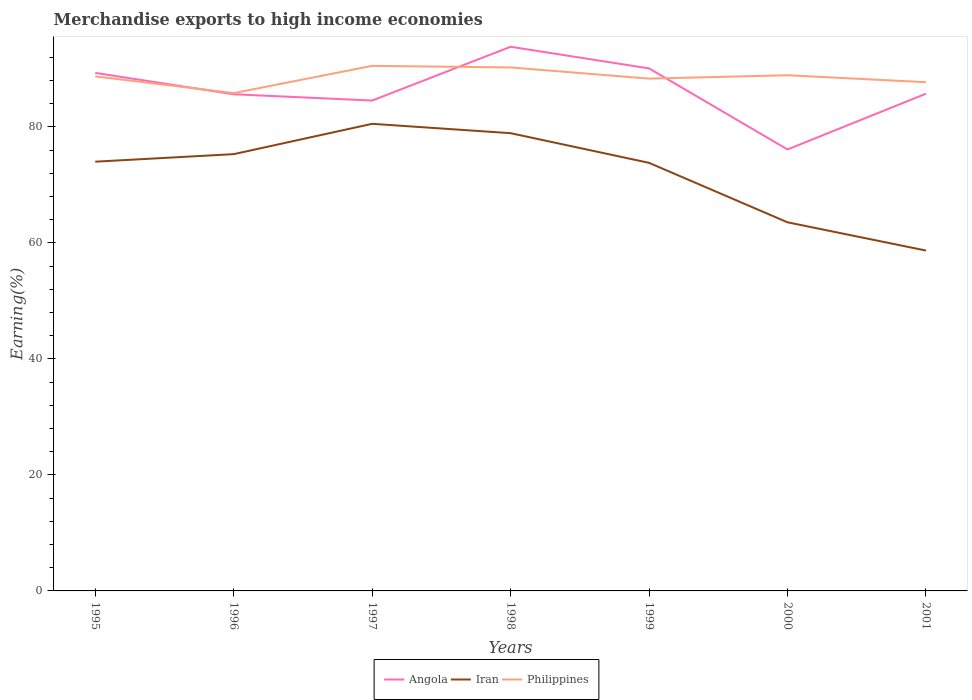How many different coloured lines are there?
Ensure brevity in your answer.  3. Is the number of lines equal to the number of legend labels?
Your answer should be very brief. Yes. Across all years, what is the maximum percentage of amount earned from merchandise exports in Iran?
Your response must be concise. 58.69. What is the total percentage of amount earned from merchandise exports in Angola in the graph?
Your response must be concise. -8.19. What is the difference between the highest and the second highest percentage of amount earned from merchandise exports in Iran?
Your response must be concise. 21.85. Is the percentage of amount earned from merchandise exports in Iran strictly greater than the percentage of amount earned from merchandise exports in Philippines over the years?
Give a very brief answer. Yes. How many lines are there?
Offer a terse response. 3. Are the values on the major ticks of Y-axis written in scientific E-notation?
Make the answer very short. No. Does the graph contain any zero values?
Provide a short and direct response. No. Does the graph contain grids?
Provide a short and direct response. No. Where does the legend appear in the graph?
Ensure brevity in your answer.  Bottom center. How many legend labels are there?
Ensure brevity in your answer.  3. What is the title of the graph?
Your answer should be compact. Merchandise exports to high income economies. What is the label or title of the Y-axis?
Provide a succinct answer. Earning(%). What is the Earning(%) of Angola in 1995?
Your answer should be very brief. 89.32. What is the Earning(%) in Iran in 1995?
Keep it short and to the point. 74.01. What is the Earning(%) in Philippines in 1995?
Give a very brief answer. 88.72. What is the Earning(%) in Angola in 1996?
Ensure brevity in your answer.  85.63. What is the Earning(%) of Iran in 1996?
Offer a very short reply. 75.31. What is the Earning(%) of Philippines in 1996?
Provide a succinct answer. 85.83. What is the Earning(%) in Angola in 1997?
Your answer should be compact. 84.55. What is the Earning(%) in Iran in 1997?
Provide a short and direct response. 80.54. What is the Earning(%) of Philippines in 1997?
Provide a succinct answer. 90.53. What is the Earning(%) in Angola in 1998?
Offer a very short reply. 93.83. What is the Earning(%) in Iran in 1998?
Your response must be concise. 78.93. What is the Earning(%) in Philippines in 1998?
Provide a succinct answer. 90.26. What is the Earning(%) of Angola in 1999?
Give a very brief answer. 90.09. What is the Earning(%) of Iran in 1999?
Give a very brief answer. 73.81. What is the Earning(%) in Philippines in 1999?
Keep it short and to the point. 88.33. What is the Earning(%) in Angola in 2000?
Give a very brief answer. 76.12. What is the Earning(%) in Iran in 2000?
Offer a terse response. 63.56. What is the Earning(%) of Philippines in 2000?
Offer a very short reply. 88.91. What is the Earning(%) in Angola in 2001?
Keep it short and to the point. 85.73. What is the Earning(%) of Iran in 2001?
Your response must be concise. 58.69. What is the Earning(%) of Philippines in 2001?
Keep it short and to the point. 87.72. Across all years, what is the maximum Earning(%) of Angola?
Ensure brevity in your answer.  93.83. Across all years, what is the maximum Earning(%) of Iran?
Provide a short and direct response. 80.54. Across all years, what is the maximum Earning(%) in Philippines?
Provide a short and direct response. 90.53. Across all years, what is the minimum Earning(%) in Angola?
Offer a terse response. 76.12. Across all years, what is the minimum Earning(%) in Iran?
Your answer should be compact. 58.69. Across all years, what is the minimum Earning(%) in Philippines?
Your answer should be compact. 85.83. What is the total Earning(%) of Angola in the graph?
Offer a very short reply. 605.28. What is the total Earning(%) in Iran in the graph?
Your response must be concise. 504.84. What is the total Earning(%) in Philippines in the graph?
Your answer should be compact. 620.31. What is the difference between the Earning(%) in Angola in 1995 and that in 1996?
Your answer should be very brief. 3.69. What is the difference between the Earning(%) of Iran in 1995 and that in 1996?
Give a very brief answer. -1.3. What is the difference between the Earning(%) in Philippines in 1995 and that in 1996?
Provide a succinct answer. 2.89. What is the difference between the Earning(%) in Angola in 1995 and that in 1997?
Provide a succinct answer. 4.77. What is the difference between the Earning(%) of Iran in 1995 and that in 1997?
Provide a succinct answer. -6.53. What is the difference between the Earning(%) in Philippines in 1995 and that in 1997?
Keep it short and to the point. -1.81. What is the difference between the Earning(%) in Angola in 1995 and that in 1998?
Offer a very short reply. -4.51. What is the difference between the Earning(%) in Iran in 1995 and that in 1998?
Offer a very short reply. -4.92. What is the difference between the Earning(%) in Philippines in 1995 and that in 1998?
Offer a terse response. -1.54. What is the difference between the Earning(%) in Angola in 1995 and that in 1999?
Keep it short and to the point. -0.78. What is the difference between the Earning(%) of Iran in 1995 and that in 1999?
Your answer should be compact. 0.2. What is the difference between the Earning(%) in Philippines in 1995 and that in 1999?
Provide a succinct answer. 0.39. What is the difference between the Earning(%) in Angola in 1995 and that in 2000?
Provide a succinct answer. 13.2. What is the difference between the Earning(%) in Iran in 1995 and that in 2000?
Offer a terse response. 10.45. What is the difference between the Earning(%) of Philippines in 1995 and that in 2000?
Give a very brief answer. -0.19. What is the difference between the Earning(%) of Angola in 1995 and that in 2001?
Your response must be concise. 3.59. What is the difference between the Earning(%) of Iran in 1995 and that in 2001?
Your answer should be very brief. 15.32. What is the difference between the Earning(%) of Angola in 1996 and that in 1997?
Offer a very short reply. 1.08. What is the difference between the Earning(%) in Iran in 1996 and that in 1997?
Offer a very short reply. -5.23. What is the difference between the Earning(%) of Philippines in 1996 and that in 1997?
Your answer should be compact. -4.7. What is the difference between the Earning(%) in Angola in 1996 and that in 1998?
Provide a succinct answer. -8.19. What is the difference between the Earning(%) of Iran in 1996 and that in 1998?
Your response must be concise. -3.62. What is the difference between the Earning(%) in Philippines in 1996 and that in 1998?
Offer a very short reply. -4.43. What is the difference between the Earning(%) of Angola in 1996 and that in 1999?
Ensure brevity in your answer.  -4.46. What is the difference between the Earning(%) of Iran in 1996 and that in 1999?
Keep it short and to the point. 1.5. What is the difference between the Earning(%) of Philippines in 1996 and that in 1999?
Your answer should be compact. -2.5. What is the difference between the Earning(%) in Angola in 1996 and that in 2000?
Provide a succinct answer. 9.52. What is the difference between the Earning(%) in Iran in 1996 and that in 2000?
Give a very brief answer. 11.75. What is the difference between the Earning(%) of Philippines in 1996 and that in 2000?
Your answer should be very brief. -3.08. What is the difference between the Earning(%) of Angola in 1996 and that in 2001?
Your answer should be compact. -0.1. What is the difference between the Earning(%) of Iran in 1996 and that in 2001?
Your response must be concise. 16.62. What is the difference between the Earning(%) of Philippines in 1996 and that in 2001?
Offer a terse response. -1.88. What is the difference between the Earning(%) in Angola in 1997 and that in 1998?
Offer a terse response. -9.27. What is the difference between the Earning(%) in Iran in 1997 and that in 1998?
Your answer should be compact. 1.61. What is the difference between the Earning(%) in Philippines in 1997 and that in 1998?
Your answer should be compact. 0.27. What is the difference between the Earning(%) in Angola in 1997 and that in 1999?
Keep it short and to the point. -5.54. What is the difference between the Earning(%) in Iran in 1997 and that in 1999?
Your answer should be very brief. 6.73. What is the difference between the Earning(%) in Philippines in 1997 and that in 1999?
Offer a very short reply. 2.2. What is the difference between the Earning(%) of Angola in 1997 and that in 2000?
Your response must be concise. 8.43. What is the difference between the Earning(%) in Iran in 1997 and that in 2000?
Your answer should be very brief. 16.98. What is the difference between the Earning(%) of Philippines in 1997 and that in 2000?
Your response must be concise. 1.62. What is the difference between the Earning(%) in Angola in 1997 and that in 2001?
Your response must be concise. -1.18. What is the difference between the Earning(%) of Iran in 1997 and that in 2001?
Give a very brief answer. 21.85. What is the difference between the Earning(%) of Philippines in 1997 and that in 2001?
Offer a very short reply. 2.82. What is the difference between the Earning(%) of Angola in 1998 and that in 1999?
Offer a terse response. 3.73. What is the difference between the Earning(%) of Iran in 1998 and that in 1999?
Keep it short and to the point. 5.12. What is the difference between the Earning(%) in Philippines in 1998 and that in 1999?
Ensure brevity in your answer.  1.93. What is the difference between the Earning(%) in Angola in 1998 and that in 2000?
Ensure brevity in your answer.  17.71. What is the difference between the Earning(%) of Iran in 1998 and that in 2000?
Provide a short and direct response. 15.37. What is the difference between the Earning(%) of Philippines in 1998 and that in 2000?
Keep it short and to the point. 1.35. What is the difference between the Earning(%) in Angola in 1998 and that in 2001?
Make the answer very short. 8.09. What is the difference between the Earning(%) in Iran in 1998 and that in 2001?
Your answer should be compact. 20.24. What is the difference between the Earning(%) in Philippines in 1998 and that in 2001?
Ensure brevity in your answer.  2.54. What is the difference between the Earning(%) of Angola in 1999 and that in 2000?
Give a very brief answer. 13.98. What is the difference between the Earning(%) in Iran in 1999 and that in 2000?
Provide a short and direct response. 10.25. What is the difference between the Earning(%) in Philippines in 1999 and that in 2000?
Your answer should be very brief. -0.58. What is the difference between the Earning(%) of Angola in 1999 and that in 2001?
Offer a very short reply. 4.36. What is the difference between the Earning(%) in Iran in 1999 and that in 2001?
Offer a terse response. 15.12. What is the difference between the Earning(%) in Philippines in 1999 and that in 2001?
Your answer should be very brief. 0.62. What is the difference between the Earning(%) of Angola in 2000 and that in 2001?
Offer a very short reply. -9.61. What is the difference between the Earning(%) in Iran in 2000 and that in 2001?
Give a very brief answer. 4.87. What is the difference between the Earning(%) of Philippines in 2000 and that in 2001?
Your response must be concise. 1.2. What is the difference between the Earning(%) in Angola in 1995 and the Earning(%) in Iran in 1996?
Your answer should be compact. 14.01. What is the difference between the Earning(%) in Angola in 1995 and the Earning(%) in Philippines in 1996?
Offer a very short reply. 3.49. What is the difference between the Earning(%) of Iran in 1995 and the Earning(%) of Philippines in 1996?
Give a very brief answer. -11.82. What is the difference between the Earning(%) of Angola in 1995 and the Earning(%) of Iran in 1997?
Provide a short and direct response. 8.78. What is the difference between the Earning(%) in Angola in 1995 and the Earning(%) in Philippines in 1997?
Make the answer very short. -1.21. What is the difference between the Earning(%) of Iran in 1995 and the Earning(%) of Philippines in 1997?
Offer a terse response. -16.52. What is the difference between the Earning(%) of Angola in 1995 and the Earning(%) of Iran in 1998?
Provide a short and direct response. 10.39. What is the difference between the Earning(%) of Angola in 1995 and the Earning(%) of Philippines in 1998?
Keep it short and to the point. -0.94. What is the difference between the Earning(%) of Iran in 1995 and the Earning(%) of Philippines in 1998?
Your answer should be very brief. -16.25. What is the difference between the Earning(%) of Angola in 1995 and the Earning(%) of Iran in 1999?
Provide a short and direct response. 15.51. What is the difference between the Earning(%) of Angola in 1995 and the Earning(%) of Philippines in 1999?
Keep it short and to the point. 0.99. What is the difference between the Earning(%) in Iran in 1995 and the Earning(%) in Philippines in 1999?
Give a very brief answer. -14.32. What is the difference between the Earning(%) of Angola in 1995 and the Earning(%) of Iran in 2000?
Make the answer very short. 25.76. What is the difference between the Earning(%) of Angola in 1995 and the Earning(%) of Philippines in 2000?
Offer a very short reply. 0.41. What is the difference between the Earning(%) of Iran in 1995 and the Earning(%) of Philippines in 2000?
Offer a very short reply. -14.9. What is the difference between the Earning(%) in Angola in 1995 and the Earning(%) in Iran in 2001?
Your answer should be compact. 30.63. What is the difference between the Earning(%) of Angola in 1995 and the Earning(%) of Philippines in 2001?
Give a very brief answer. 1.6. What is the difference between the Earning(%) in Iran in 1995 and the Earning(%) in Philippines in 2001?
Offer a terse response. -13.7. What is the difference between the Earning(%) in Angola in 1996 and the Earning(%) in Iran in 1997?
Offer a very short reply. 5.09. What is the difference between the Earning(%) in Angola in 1996 and the Earning(%) in Philippines in 1997?
Provide a succinct answer. -4.9. What is the difference between the Earning(%) of Iran in 1996 and the Earning(%) of Philippines in 1997?
Your answer should be very brief. -15.22. What is the difference between the Earning(%) of Angola in 1996 and the Earning(%) of Iran in 1998?
Provide a short and direct response. 6.71. What is the difference between the Earning(%) of Angola in 1996 and the Earning(%) of Philippines in 1998?
Provide a succinct answer. -4.63. What is the difference between the Earning(%) of Iran in 1996 and the Earning(%) of Philippines in 1998?
Give a very brief answer. -14.95. What is the difference between the Earning(%) of Angola in 1996 and the Earning(%) of Iran in 1999?
Make the answer very short. 11.83. What is the difference between the Earning(%) in Angola in 1996 and the Earning(%) in Philippines in 1999?
Keep it short and to the point. -2.7. What is the difference between the Earning(%) in Iran in 1996 and the Earning(%) in Philippines in 1999?
Your answer should be compact. -13.02. What is the difference between the Earning(%) in Angola in 1996 and the Earning(%) in Iran in 2000?
Offer a very short reply. 22.08. What is the difference between the Earning(%) of Angola in 1996 and the Earning(%) of Philippines in 2000?
Offer a very short reply. -3.28. What is the difference between the Earning(%) in Iran in 1996 and the Earning(%) in Philippines in 2000?
Make the answer very short. -13.6. What is the difference between the Earning(%) of Angola in 1996 and the Earning(%) of Iran in 2001?
Your answer should be very brief. 26.95. What is the difference between the Earning(%) in Angola in 1996 and the Earning(%) in Philippines in 2001?
Your answer should be compact. -2.08. What is the difference between the Earning(%) of Iran in 1996 and the Earning(%) of Philippines in 2001?
Give a very brief answer. -12.41. What is the difference between the Earning(%) of Angola in 1997 and the Earning(%) of Iran in 1998?
Your answer should be compact. 5.63. What is the difference between the Earning(%) in Angola in 1997 and the Earning(%) in Philippines in 1998?
Make the answer very short. -5.71. What is the difference between the Earning(%) of Iran in 1997 and the Earning(%) of Philippines in 1998?
Offer a terse response. -9.72. What is the difference between the Earning(%) of Angola in 1997 and the Earning(%) of Iran in 1999?
Provide a short and direct response. 10.74. What is the difference between the Earning(%) in Angola in 1997 and the Earning(%) in Philippines in 1999?
Ensure brevity in your answer.  -3.78. What is the difference between the Earning(%) of Iran in 1997 and the Earning(%) of Philippines in 1999?
Provide a short and direct response. -7.79. What is the difference between the Earning(%) in Angola in 1997 and the Earning(%) in Iran in 2000?
Your answer should be very brief. 20.99. What is the difference between the Earning(%) of Angola in 1997 and the Earning(%) of Philippines in 2000?
Your answer should be very brief. -4.36. What is the difference between the Earning(%) of Iran in 1997 and the Earning(%) of Philippines in 2000?
Your response must be concise. -8.37. What is the difference between the Earning(%) in Angola in 1997 and the Earning(%) in Iran in 2001?
Keep it short and to the point. 25.86. What is the difference between the Earning(%) in Angola in 1997 and the Earning(%) in Philippines in 2001?
Provide a short and direct response. -3.16. What is the difference between the Earning(%) in Iran in 1997 and the Earning(%) in Philippines in 2001?
Give a very brief answer. -7.18. What is the difference between the Earning(%) in Angola in 1998 and the Earning(%) in Iran in 1999?
Your answer should be compact. 20.02. What is the difference between the Earning(%) of Angola in 1998 and the Earning(%) of Philippines in 1999?
Make the answer very short. 5.49. What is the difference between the Earning(%) in Iran in 1998 and the Earning(%) in Philippines in 1999?
Your response must be concise. -9.41. What is the difference between the Earning(%) of Angola in 1998 and the Earning(%) of Iran in 2000?
Make the answer very short. 30.27. What is the difference between the Earning(%) of Angola in 1998 and the Earning(%) of Philippines in 2000?
Ensure brevity in your answer.  4.91. What is the difference between the Earning(%) of Iran in 1998 and the Earning(%) of Philippines in 2000?
Offer a very short reply. -9.99. What is the difference between the Earning(%) of Angola in 1998 and the Earning(%) of Iran in 2001?
Ensure brevity in your answer.  35.14. What is the difference between the Earning(%) of Angola in 1998 and the Earning(%) of Philippines in 2001?
Make the answer very short. 6.11. What is the difference between the Earning(%) in Iran in 1998 and the Earning(%) in Philippines in 2001?
Your answer should be very brief. -8.79. What is the difference between the Earning(%) of Angola in 1999 and the Earning(%) of Iran in 2000?
Offer a terse response. 26.54. What is the difference between the Earning(%) of Angola in 1999 and the Earning(%) of Philippines in 2000?
Offer a very short reply. 1.18. What is the difference between the Earning(%) of Iran in 1999 and the Earning(%) of Philippines in 2000?
Keep it short and to the point. -15.11. What is the difference between the Earning(%) in Angola in 1999 and the Earning(%) in Iran in 2001?
Provide a short and direct response. 31.41. What is the difference between the Earning(%) in Angola in 1999 and the Earning(%) in Philippines in 2001?
Make the answer very short. 2.38. What is the difference between the Earning(%) in Iran in 1999 and the Earning(%) in Philippines in 2001?
Keep it short and to the point. -13.91. What is the difference between the Earning(%) of Angola in 2000 and the Earning(%) of Iran in 2001?
Your response must be concise. 17.43. What is the difference between the Earning(%) in Angola in 2000 and the Earning(%) in Philippines in 2001?
Provide a succinct answer. -11.6. What is the difference between the Earning(%) in Iran in 2000 and the Earning(%) in Philippines in 2001?
Your answer should be very brief. -24.16. What is the average Earning(%) in Angola per year?
Ensure brevity in your answer.  86.47. What is the average Earning(%) of Iran per year?
Keep it short and to the point. 72.12. What is the average Earning(%) of Philippines per year?
Offer a very short reply. 88.62. In the year 1995, what is the difference between the Earning(%) of Angola and Earning(%) of Iran?
Give a very brief answer. 15.31. In the year 1995, what is the difference between the Earning(%) of Angola and Earning(%) of Philippines?
Make the answer very short. 0.6. In the year 1995, what is the difference between the Earning(%) in Iran and Earning(%) in Philippines?
Your answer should be very brief. -14.71. In the year 1996, what is the difference between the Earning(%) in Angola and Earning(%) in Iran?
Ensure brevity in your answer.  10.32. In the year 1996, what is the difference between the Earning(%) in Angola and Earning(%) in Philippines?
Keep it short and to the point. -0.2. In the year 1996, what is the difference between the Earning(%) in Iran and Earning(%) in Philippines?
Your answer should be compact. -10.52. In the year 1997, what is the difference between the Earning(%) of Angola and Earning(%) of Iran?
Your answer should be very brief. 4.01. In the year 1997, what is the difference between the Earning(%) in Angola and Earning(%) in Philippines?
Give a very brief answer. -5.98. In the year 1997, what is the difference between the Earning(%) of Iran and Earning(%) of Philippines?
Provide a succinct answer. -9.99. In the year 1998, what is the difference between the Earning(%) in Angola and Earning(%) in Iran?
Give a very brief answer. 14.9. In the year 1998, what is the difference between the Earning(%) in Angola and Earning(%) in Philippines?
Make the answer very short. 3.57. In the year 1998, what is the difference between the Earning(%) in Iran and Earning(%) in Philippines?
Your response must be concise. -11.33. In the year 1999, what is the difference between the Earning(%) of Angola and Earning(%) of Iran?
Make the answer very short. 16.29. In the year 1999, what is the difference between the Earning(%) in Angola and Earning(%) in Philippines?
Offer a terse response. 1.76. In the year 1999, what is the difference between the Earning(%) in Iran and Earning(%) in Philippines?
Ensure brevity in your answer.  -14.52. In the year 2000, what is the difference between the Earning(%) of Angola and Earning(%) of Iran?
Give a very brief answer. 12.56. In the year 2000, what is the difference between the Earning(%) in Angola and Earning(%) in Philippines?
Make the answer very short. -12.79. In the year 2000, what is the difference between the Earning(%) in Iran and Earning(%) in Philippines?
Your answer should be compact. -25.36. In the year 2001, what is the difference between the Earning(%) in Angola and Earning(%) in Iran?
Provide a short and direct response. 27.04. In the year 2001, what is the difference between the Earning(%) of Angola and Earning(%) of Philippines?
Make the answer very short. -1.98. In the year 2001, what is the difference between the Earning(%) in Iran and Earning(%) in Philippines?
Your response must be concise. -29.03. What is the ratio of the Earning(%) of Angola in 1995 to that in 1996?
Keep it short and to the point. 1.04. What is the ratio of the Earning(%) in Iran in 1995 to that in 1996?
Ensure brevity in your answer.  0.98. What is the ratio of the Earning(%) in Philippines in 1995 to that in 1996?
Ensure brevity in your answer.  1.03. What is the ratio of the Earning(%) of Angola in 1995 to that in 1997?
Give a very brief answer. 1.06. What is the ratio of the Earning(%) in Iran in 1995 to that in 1997?
Give a very brief answer. 0.92. What is the ratio of the Earning(%) in Iran in 1995 to that in 1998?
Provide a succinct answer. 0.94. What is the ratio of the Earning(%) of Philippines in 1995 to that in 1998?
Offer a very short reply. 0.98. What is the ratio of the Earning(%) in Philippines in 1995 to that in 1999?
Provide a succinct answer. 1. What is the ratio of the Earning(%) in Angola in 1995 to that in 2000?
Offer a very short reply. 1.17. What is the ratio of the Earning(%) in Iran in 1995 to that in 2000?
Your answer should be very brief. 1.16. What is the ratio of the Earning(%) of Philippines in 1995 to that in 2000?
Provide a succinct answer. 1. What is the ratio of the Earning(%) in Angola in 1995 to that in 2001?
Give a very brief answer. 1.04. What is the ratio of the Earning(%) of Iran in 1995 to that in 2001?
Give a very brief answer. 1.26. What is the ratio of the Earning(%) in Philippines in 1995 to that in 2001?
Your response must be concise. 1.01. What is the ratio of the Earning(%) in Angola in 1996 to that in 1997?
Provide a short and direct response. 1.01. What is the ratio of the Earning(%) of Iran in 1996 to that in 1997?
Make the answer very short. 0.94. What is the ratio of the Earning(%) in Philippines in 1996 to that in 1997?
Make the answer very short. 0.95. What is the ratio of the Earning(%) of Angola in 1996 to that in 1998?
Ensure brevity in your answer.  0.91. What is the ratio of the Earning(%) in Iran in 1996 to that in 1998?
Make the answer very short. 0.95. What is the ratio of the Earning(%) of Philippines in 1996 to that in 1998?
Keep it short and to the point. 0.95. What is the ratio of the Earning(%) in Angola in 1996 to that in 1999?
Provide a succinct answer. 0.95. What is the ratio of the Earning(%) in Iran in 1996 to that in 1999?
Your response must be concise. 1.02. What is the ratio of the Earning(%) of Philippines in 1996 to that in 1999?
Ensure brevity in your answer.  0.97. What is the ratio of the Earning(%) of Iran in 1996 to that in 2000?
Your answer should be very brief. 1.18. What is the ratio of the Earning(%) of Philippines in 1996 to that in 2000?
Your response must be concise. 0.97. What is the ratio of the Earning(%) of Angola in 1996 to that in 2001?
Your response must be concise. 1. What is the ratio of the Earning(%) of Iran in 1996 to that in 2001?
Your response must be concise. 1.28. What is the ratio of the Earning(%) of Philippines in 1996 to that in 2001?
Provide a succinct answer. 0.98. What is the ratio of the Earning(%) in Angola in 1997 to that in 1998?
Make the answer very short. 0.9. What is the ratio of the Earning(%) of Iran in 1997 to that in 1998?
Offer a terse response. 1.02. What is the ratio of the Earning(%) in Angola in 1997 to that in 1999?
Give a very brief answer. 0.94. What is the ratio of the Earning(%) of Iran in 1997 to that in 1999?
Give a very brief answer. 1.09. What is the ratio of the Earning(%) in Philippines in 1997 to that in 1999?
Provide a short and direct response. 1.02. What is the ratio of the Earning(%) in Angola in 1997 to that in 2000?
Your response must be concise. 1.11. What is the ratio of the Earning(%) of Iran in 1997 to that in 2000?
Your response must be concise. 1.27. What is the ratio of the Earning(%) of Philippines in 1997 to that in 2000?
Ensure brevity in your answer.  1.02. What is the ratio of the Earning(%) in Angola in 1997 to that in 2001?
Offer a very short reply. 0.99. What is the ratio of the Earning(%) in Iran in 1997 to that in 2001?
Your answer should be very brief. 1.37. What is the ratio of the Earning(%) of Philippines in 1997 to that in 2001?
Give a very brief answer. 1.03. What is the ratio of the Earning(%) in Angola in 1998 to that in 1999?
Your answer should be very brief. 1.04. What is the ratio of the Earning(%) in Iran in 1998 to that in 1999?
Provide a succinct answer. 1.07. What is the ratio of the Earning(%) in Philippines in 1998 to that in 1999?
Keep it short and to the point. 1.02. What is the ratio of the Earning(%) of Angola in 1998 to that in 2000?
Provide a succinct answer. 1.23. What is the ratio of the Earning(%) of Iran in 1998 to that in 2000?
Keep it short and to the point. 1.24. What is the ratio of the Earning(%) in Philippines in 1998 to that in 2000?
Offer a very short reply. 1.02. What is the ratio of the Earning(%) in Angola in 1998 to that in 2001?
Offer a terse response. 1.09. What is the ratio of the Earning(%) of Iran in 1998 to that in 2001?
Give a very brief answer. 1.34. What is the ratio of the Earning(%) in Philippines in 1998 to that in 2001?
Provide a succinct answer. 1.03. What is the ratio of the Earning(%) in Angola in 1999 to that in 2000?
Give a very brief answer. 1.18. What is the ratio of the Earning(%) of Iran in 1999 to that in 2000?
Provide a succinct answer. 1.16. What is the ratio of the Earning(%) of Philippines in 1999 to that in 2000?
Offer a terse response. 0.99. What is the ratio of the Earning(%) in Angola in 1999 to that in 2001?
Your answer should be compact. 1.05. What is the ratio of the Earning(%) in Iran in 1999 to that in 2001?
Offer a terse response. 1.26. What is the ratio of the Earning(%) in Angola in 2000 to that in 2001?
Offer a terse response. 0.89. What is the ratio of the Earning(%) of Iran in 2000 to that in 2001?
Your answer should be very brief. 1.08. What is the ratio of the Earning(%) of Philippines in 2000 to that in 2001?
Your response must be concise. 1.01. What is the difference between the highest and the second highest Earning(%) of Angola?
Your answer should be compact. 3.73. What is the difference between the highest and the second highest Earning(%) of Iran?
Keep it short and to the point. 1.61. What is the difference between the highest and the second highest Earning(%) of Philippines?
Your answer should be compact. 0.27. What is the difference between the highest and the lowest Earning(%) in Angola?
Offer a very short reply. 17.71. What is the difference between the highest and the lowest Earning(%) in Iran?
Provide a short and direct response. 21.85. What is the difference between the highest and the lowest Earning(%) in Philippines?
Your answer should be compact. 4.7. 